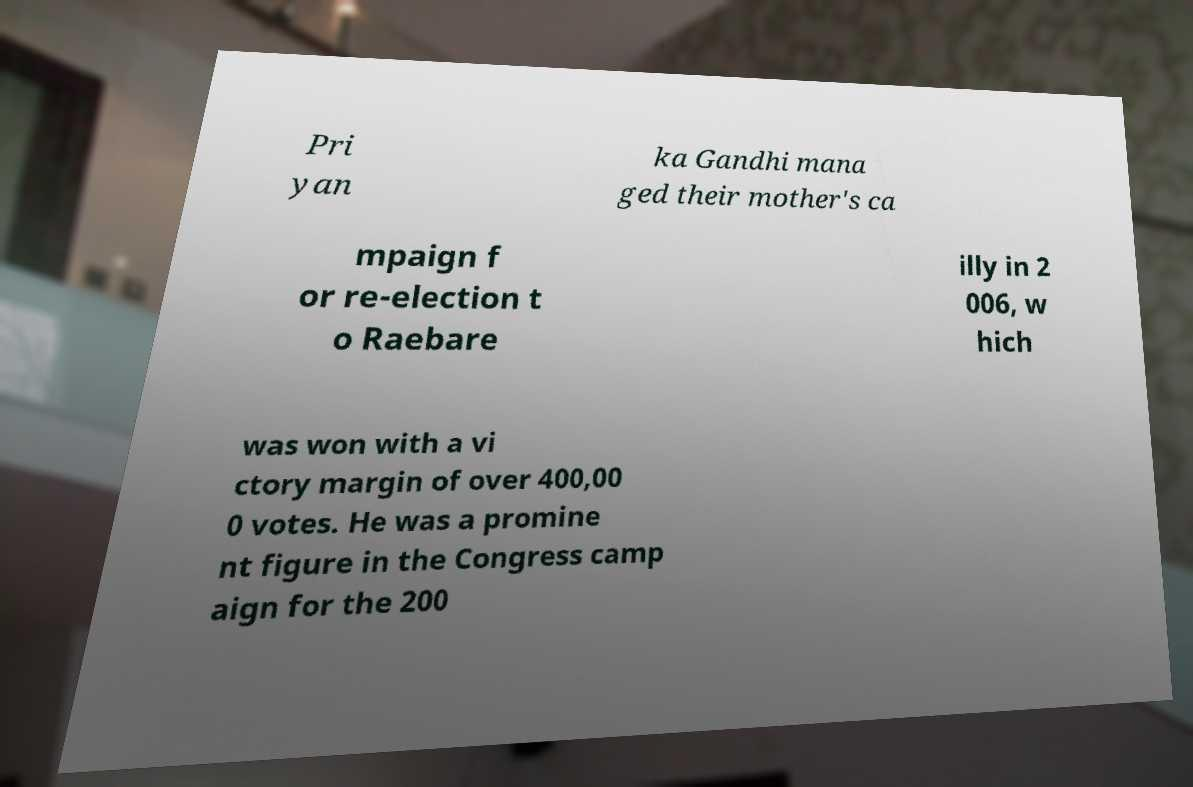For documentation purposes, I need the text within this image transcribed. Could you provide that? Pri yan ka Gandhi mana ged their mother's ca mpaign f or re-election t o Raebare illy in 2 006, w hich was won with a vi ctory margin of over 400,00 0 votes. He was a promine nt figure in the Congress camp aign for the 200 